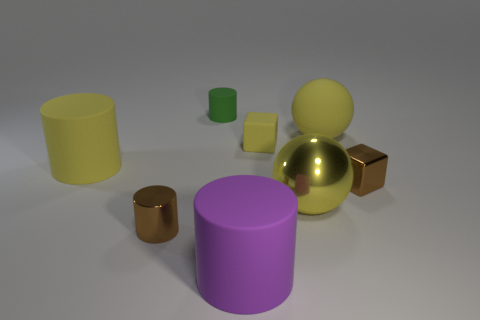Subtract all yellow cylinders. How many cylinders are left? 3 Subtract all green cylinders. How many cylinders are left? 3 Add 2 tiny purple shiny balls. How many objects exist? 10 Subtract 1 cylinders. How many cylinders are left? 3 Subtract all red cylinders. Subtract all green cubes. How many cylinders are left? 4 Subtract all spheres. How many objects are left? 6 Add 2 large purple matte objects. How many large purple matte objects are left? 3 Add 1 small brown metal objects. How many small brown metal objects exist? 3 Subtract 0 cyan spheres. How many objects are left? 8 Subtract all purple things. Subtract all tiny brown shiny blocks. How many objects are left? 6 